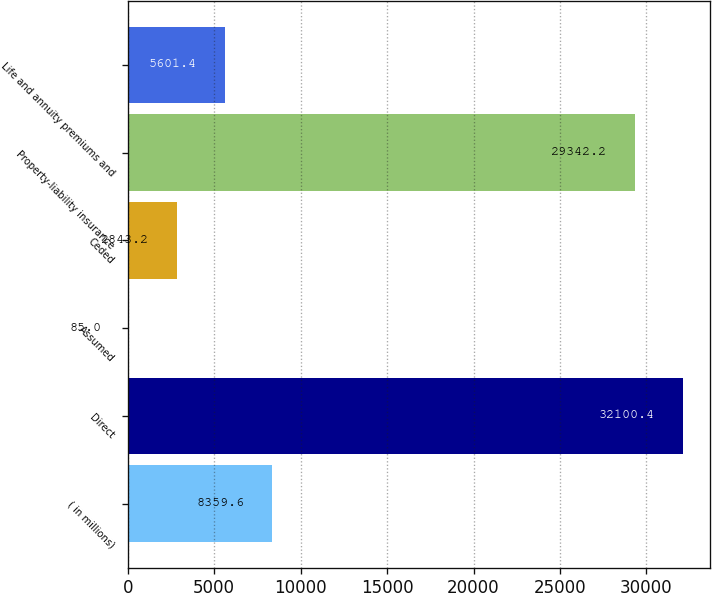Convert chart. <chart><loc_0><loc_0><loc_500><loc_500><bar_chart><fcel>( in millions)<fcel>Direct<fcel>Assumed<fcel>Ceded<fcel>Property-liability insurance<fcel>Life and annuity premiums and<nl><fcel>8359.6<fcel>32100.4<fcel>85<fcel>2843.2<fcel>29342.2<fcel>5601.4<nl></chart> 